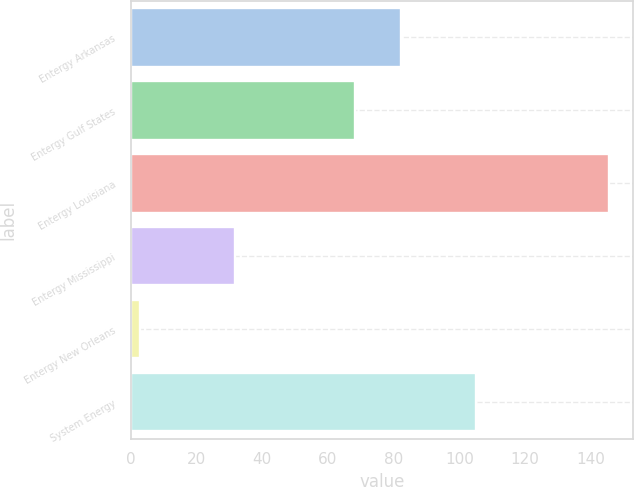<chart> <loc_0><loc_0><loc_500><loc_500><bar_chart><fcel>Entergy Arkansas<fcel>Entergy Gulf States<fcel>Entergy Louisiana<fcel>Entergy Mississippi<fcel>Entergy New Orleans<fcel>System Energy<nl><fcel>82.35<fcel>68.1<fcel>145.5<fcel>31.7<fcel>3<fcel>105<nl></chart> 